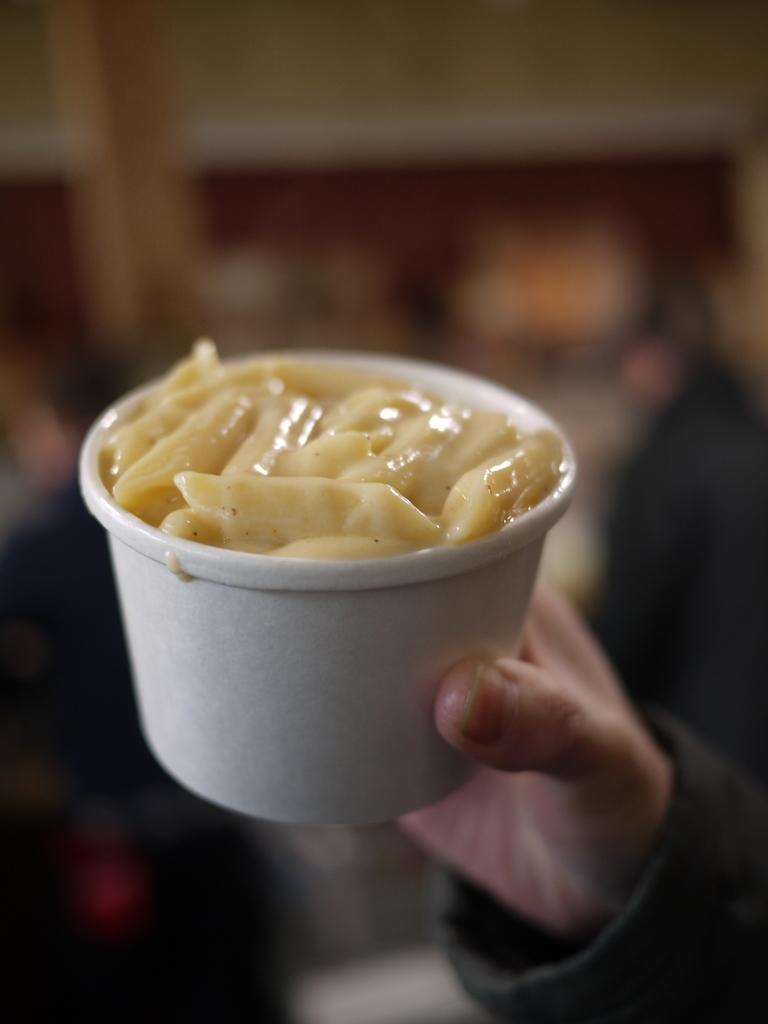Who is the main subject in the foreground of the image? There is a person in the foreground of the image. What is the person holding in the image? The person is holding a cup. What is inside the cup that the person is holding? There is pasta in the cup. Can you describe the background of the image? The background of the image is blurred. What decision is the person making in the image? There is no indication in the image that the person is making a decision. What is the condition of the person's neck in the image? There is no information about the person's neck in the image. 